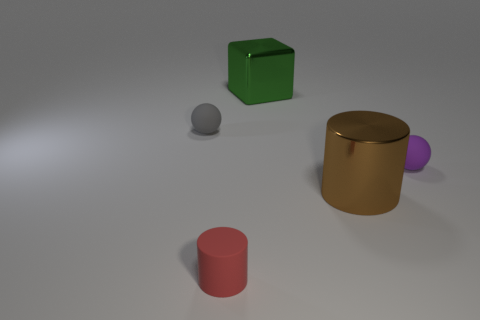How many small objects are red rubber cylinders or cyan metal objects?
Keep it short and to the point. 1. How many other tiny things are the same shape as the tiny red rubber thing?
Provide a short and direct response. 0. Does the green thing have the same shape as the small thing that is on the right side of the tiny red rubber cylinder?
Your response must be concise. No. How many metallic cubes are behind the purple object?
Ensure brevity in your answer.  1. Is there a thing of the same size as the gray ball?
Provide a succinct answer. Yes. There is a rubber thing that is on the right side of the red cylinder; does it have the same shape as the gray object?
Give a very brief answer. Yes. The big cylinder has what color?
Ensure brevity in your answer.  Brown. Are there any big gray cylinders?
Your answer should be compact. No. The cylinder that is made of the same material as the big green thing is what size?
Keep it short and to the point. Large. There is a shiny object in front of the small ball on the left side of the block that is behind the purple rubber sphere; what shape is it?
Provide a succinct answer. Cylinder. 